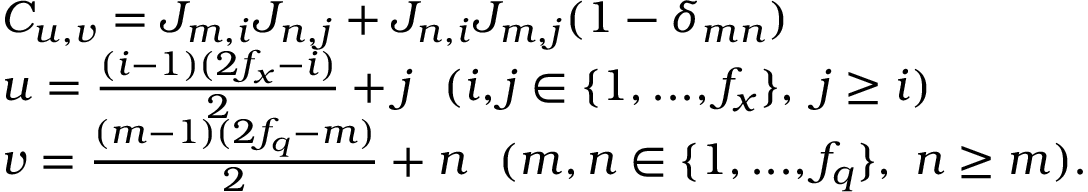Convert formula to latex. <formula><loc_0><loc_0><loc_500><loc_500>\begin{array} { r l } & { C _ { u , v } = J _ { m , i } J _ { n , j } + J _ { n , i } J _ { m , j } ( 1 - \delta _ { m n } ) } \\ & { u = \frac { ( i - 1 ) ( 2 f _ { x } - i ) } { 2 } + j ( i , j \in \{ 1 , \dots , f _ { x } \} , j \geq i ) } \\ & { v = \frac { ( m - 1 ) ( 2 f _ { q } - m ) } { 2 } + n ( m , n \in \{ 1 , \dots , f _ { q } \} , n \geq m ) . } \end{array}</formula> 